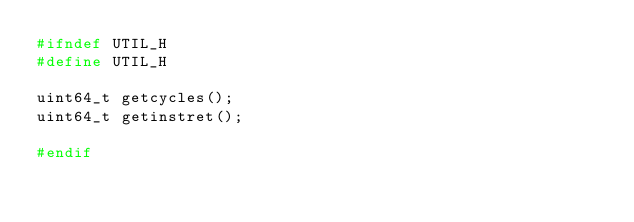<code> <loc_0><loc_0><loc_500><loc_500><_C_>#ifndef UTIL_H
#define UTIL_H

uint64_t getcycles();
uint64_t getinstret();

#endif
</code> 